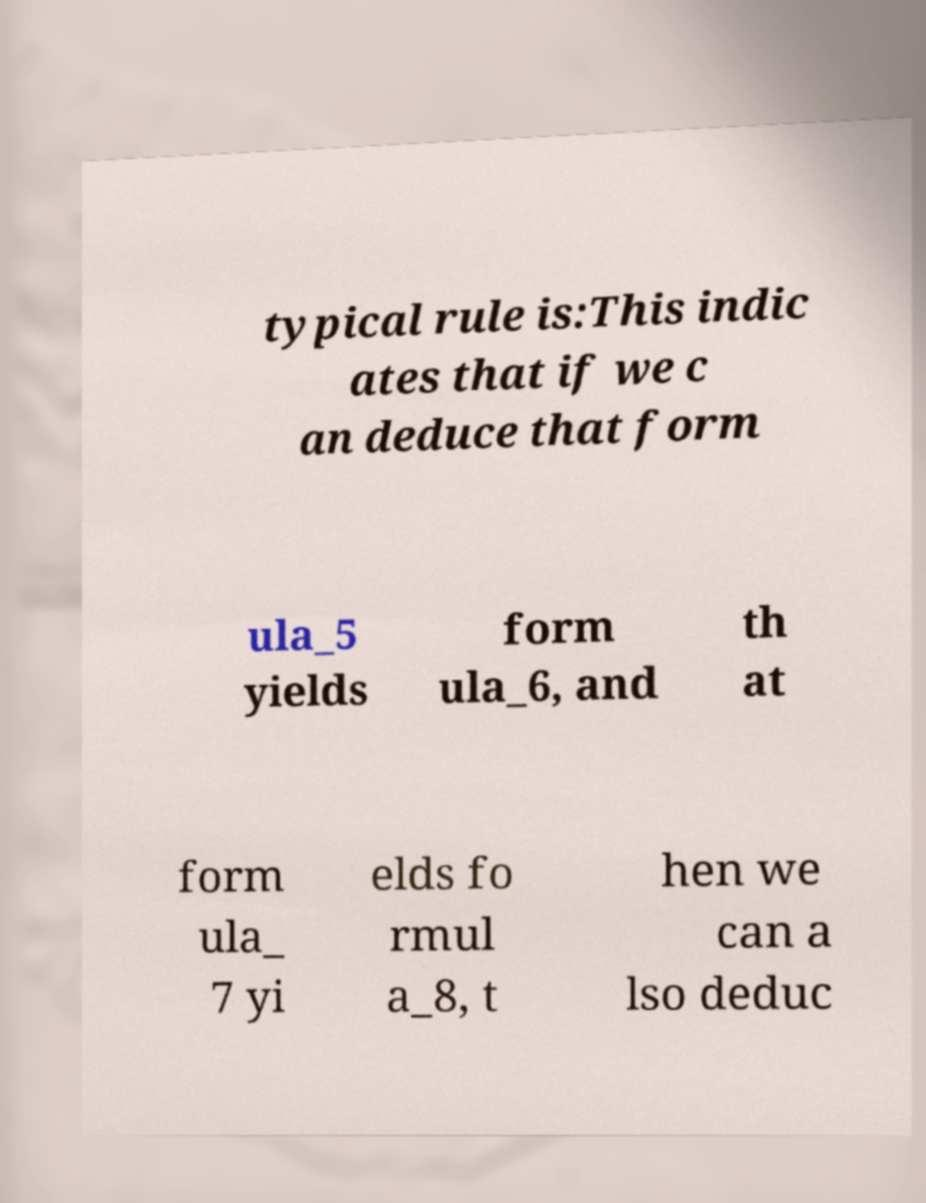Can you accurately transcribe the text from the provided image for me? typical rule is:This indic ates that if we c an deduce that form ula_5 yields form ula_6, and th at form ula_ 7 yi elds fo rmul a_8, t hen we can a lso deduc 